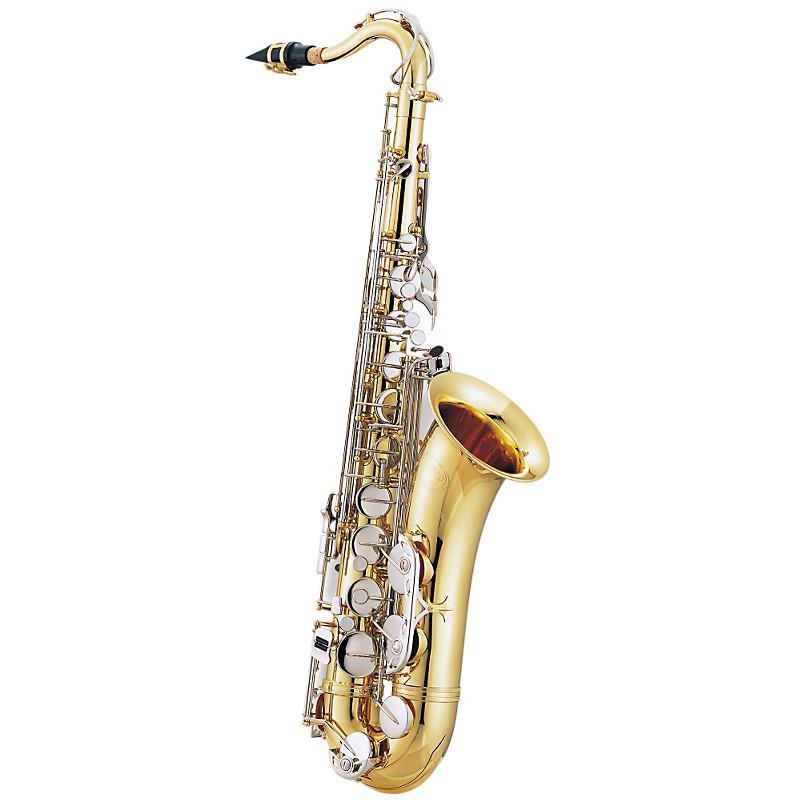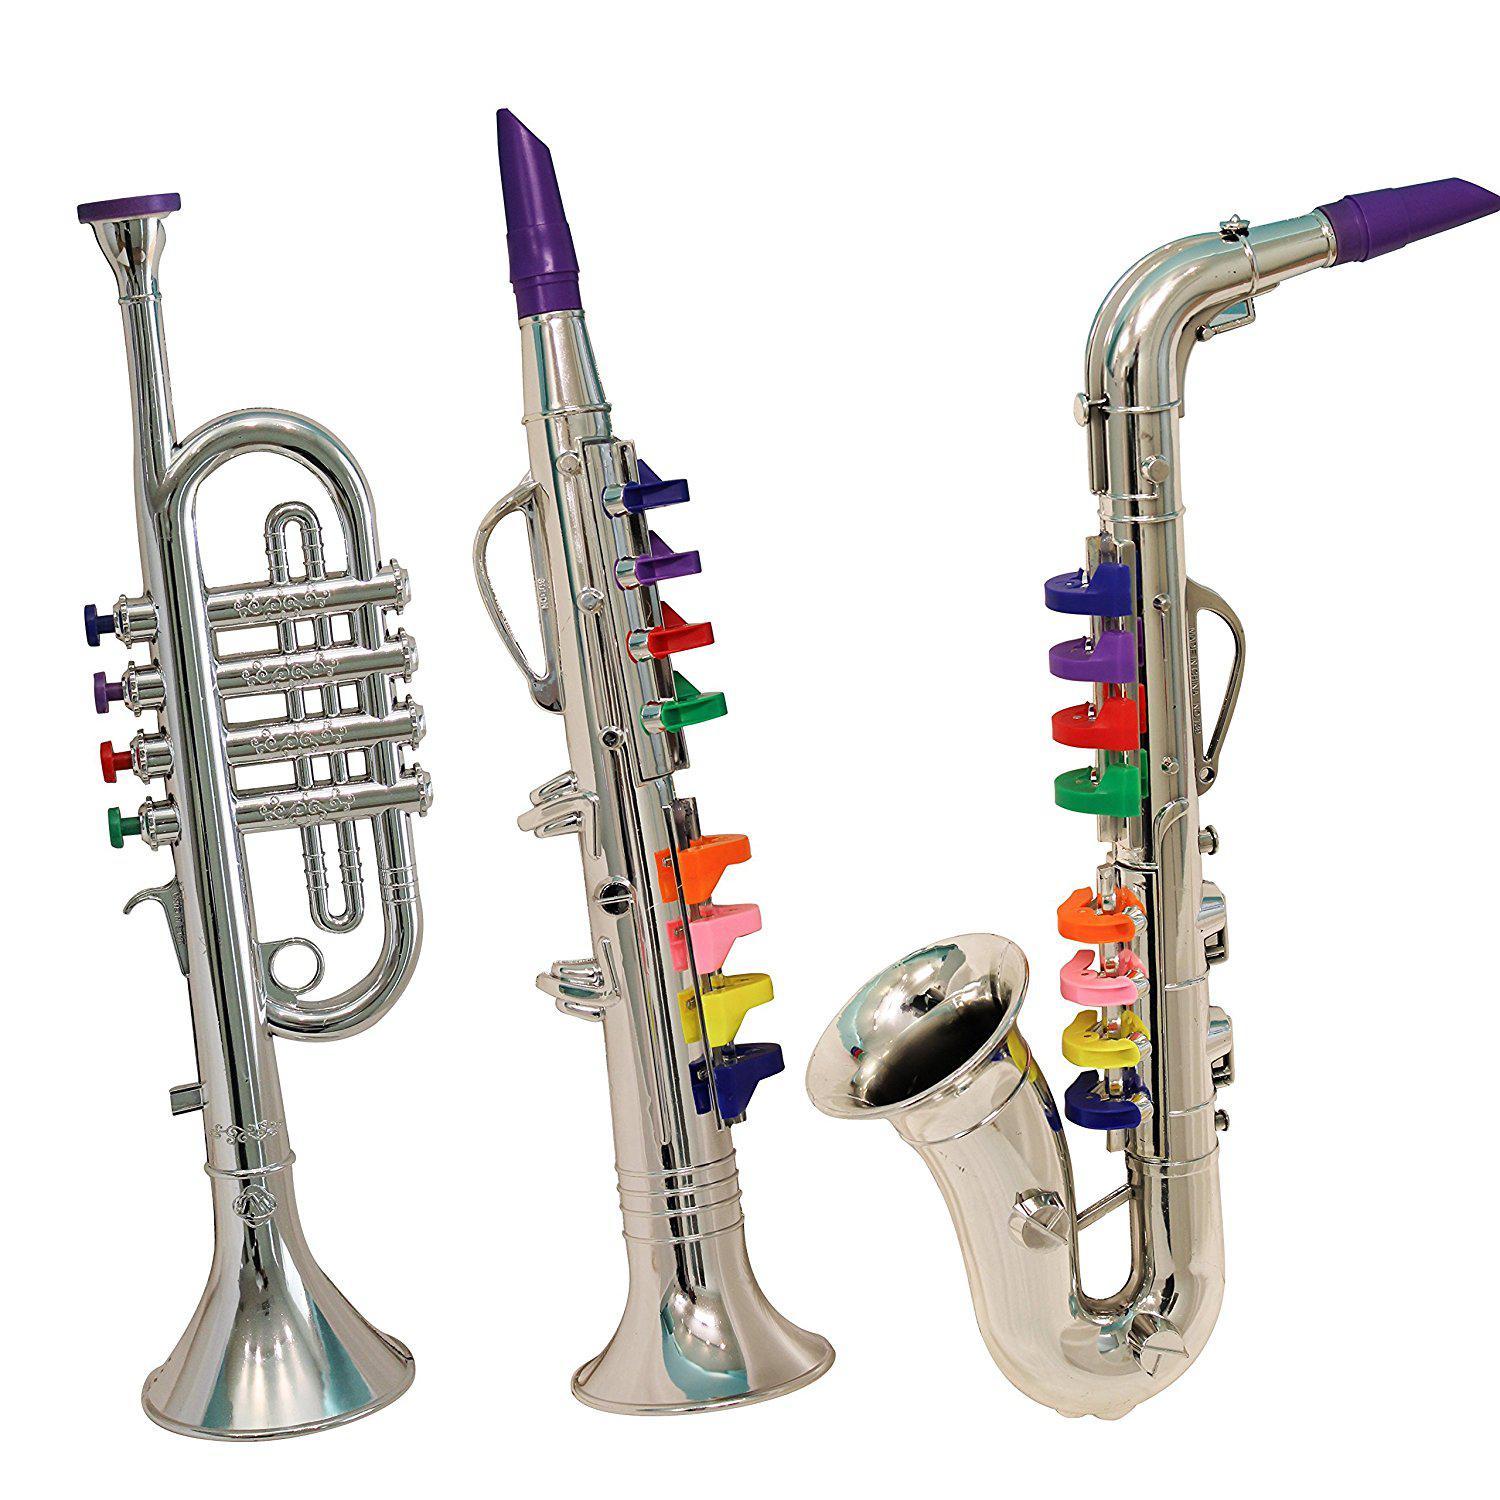The first image is the image on the left, the second image is the image on the right. Examine the images to the left and right. Is the description "In one image, a child wearing jeans is leaning back as he or she plays a saxophone." accurate? Answer yes or no. No. The first image is the image on the left, the second image is the image on the right. Considering the images on both sides, is "The right image contains a human child playing a saxophone." valid? Answer yes or no. No. 